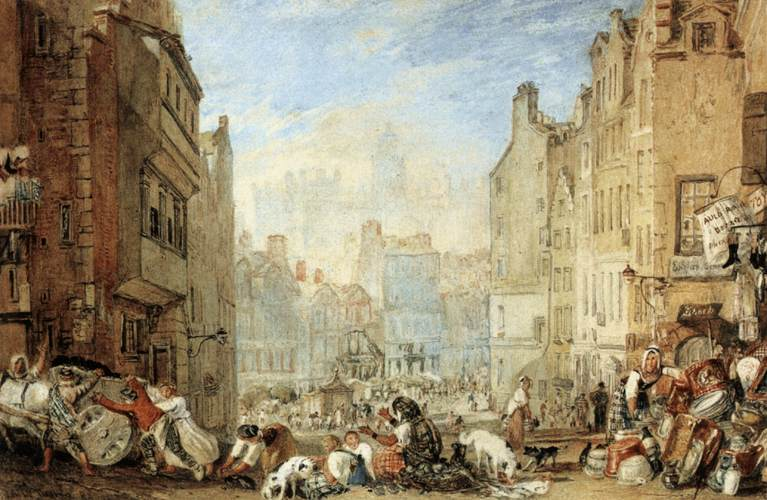Describe the following image. The image depicts a vibrant street scene in what appears to be a European city during an earlier century, characterized by dense, aging architecture and a lively urban atmosphere. The streets are bustling with people engaged in various activities, suggesting a communal or market day with goods being bought and sold. Several animals, likely pets or livestock, contribute to the scene's lively nature. The buildings, with their worn facades and distinct styles, suggest a rich history and the passage of many generations. The art style, with its detailed yet somewhat loose brushwork, enhances the dynamic and somewhat chaotic feel of the scene. This painting not only captures a moment in time but also invokes the daily life and energy typical of a densely populated urban area from the past. Overall, this scene is a beautiful representation of historical urban life, depicted with skillful artistry in color and composition. 